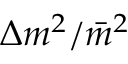<formula> <loc_0><loc_0><loc_500><loc_500>\Delta m ^ { 2 } / \bar { m } ^ { 2 }</formula> 